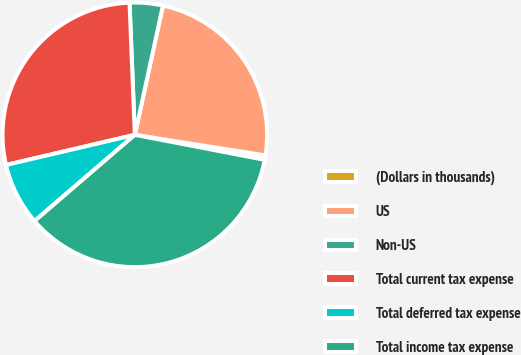Convert chart to OTSL. <chart><loc_0><loc_0><loc_500><loc_500><pie_chart><fcel>(Dollars in thousands)<fcel>US<fcel>Non-US<fcel>Total current tax expense<fcel>Total deferred tax expense<fcel>Total income tax expense<nl><fcel>0.54%<fcel>24.08%<fcel>4.05%<fcel>28.02%<fcel>7.64%<fcel>35.67%<nl></chart> 